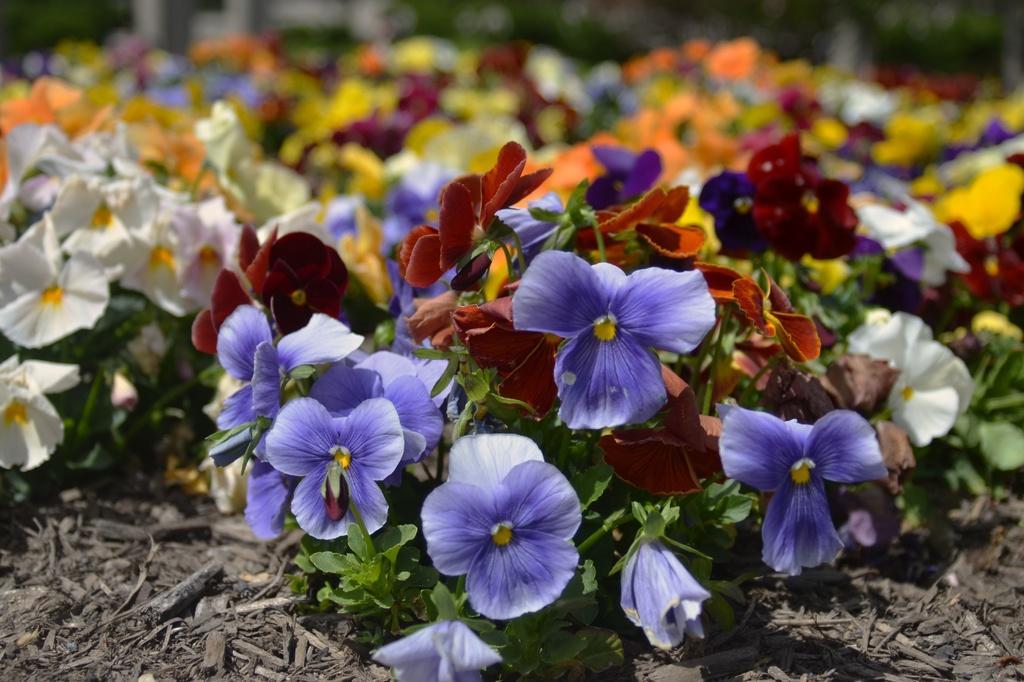Describe this image in one or two sentences. In this image there are different types of flowers, and at the bottom there is some scrap. 